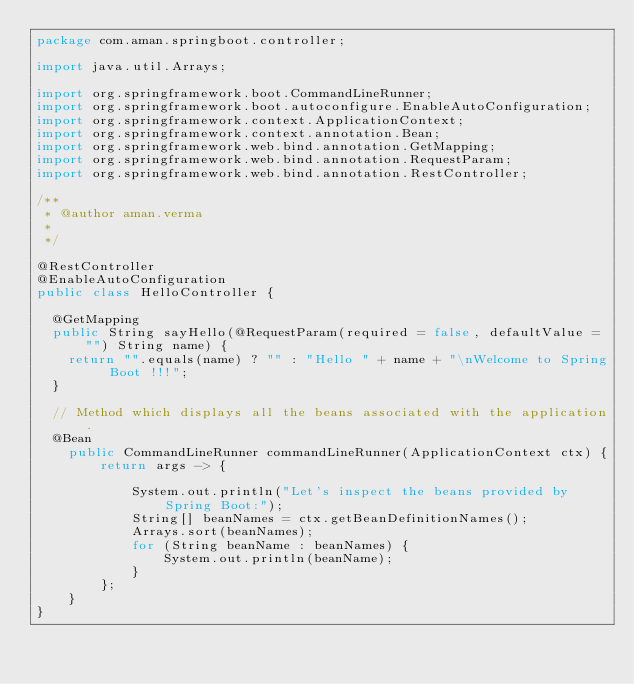<code> <loc_0><loc_0><loc_500><loc_500><_Java_>package com.aman.springboot.controller;

import java.util.Arrays;

import org.springframework.boot.CommandLineRunner;
import org.springframework.boot.autoconfigure.EnableAutoConfiguration;
import org.springframework.context.ApplicationContext;
import org.springframework.context.annotation.Bean;
import org.springframework.web.bind.annotation.GetMapping;
import org.springframework.web.bind.annotation.RequestParam;
import org.springframework.web.bind.annotation.RestController;

/**
 * @author aman.verma
 *
 */

@RestController
@EnableAutoConfiguration
public class HelloController {

	@GetMapping
	public String sayHello(@RequestParam(required = false, defaultValue = "") String name) {
		return "".equals(name) ? "" : "Hello " + name + "\nWelcome to Spring Boot !!!";
	}
	
	// Method which displays all the beans associated with the application.
	@Bean
    public CommandLineRunner commandLineRunner(ApplicationContext ctx) {
        return args -> {

            System.out.println("Let's inspect the beans provided by Spring Boot:");
            String[] beanNames = ctx.getBeanDefinitionNames();
            Arrays.sort(beanNames);
            for (String beanName : beanNames) {
                System.out.println(beanName);
            }
        };
    }
}
</code> 